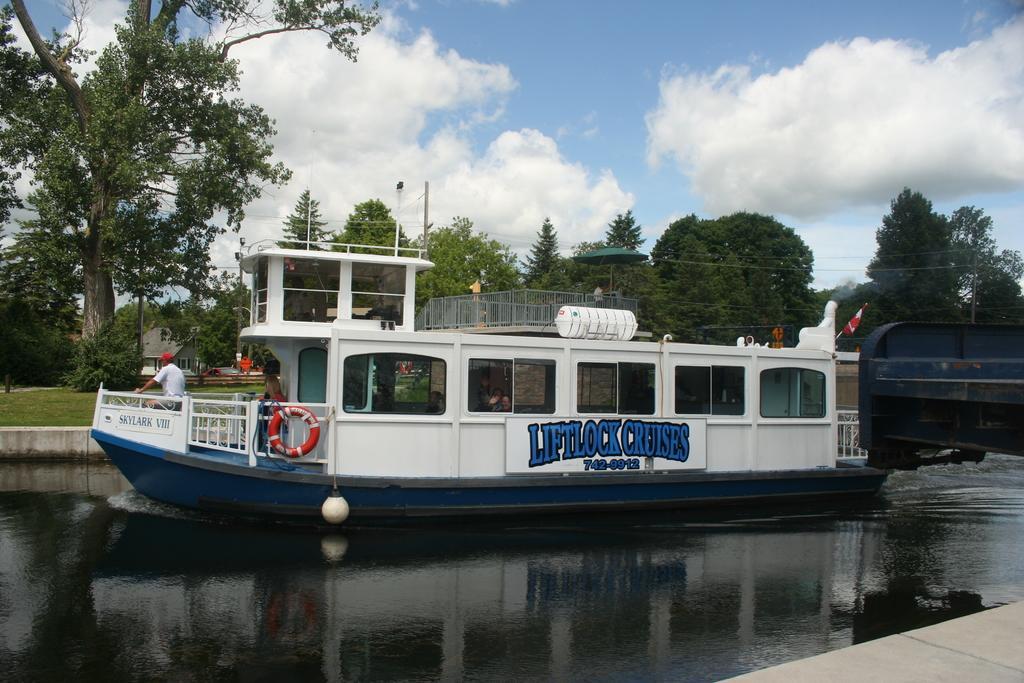Could you give a brief overview of what you see in this image? In the middle of the image we can see a boat on the water and we can see few people in the boat, in the background we can find few trees, poles, houses and clouds. 